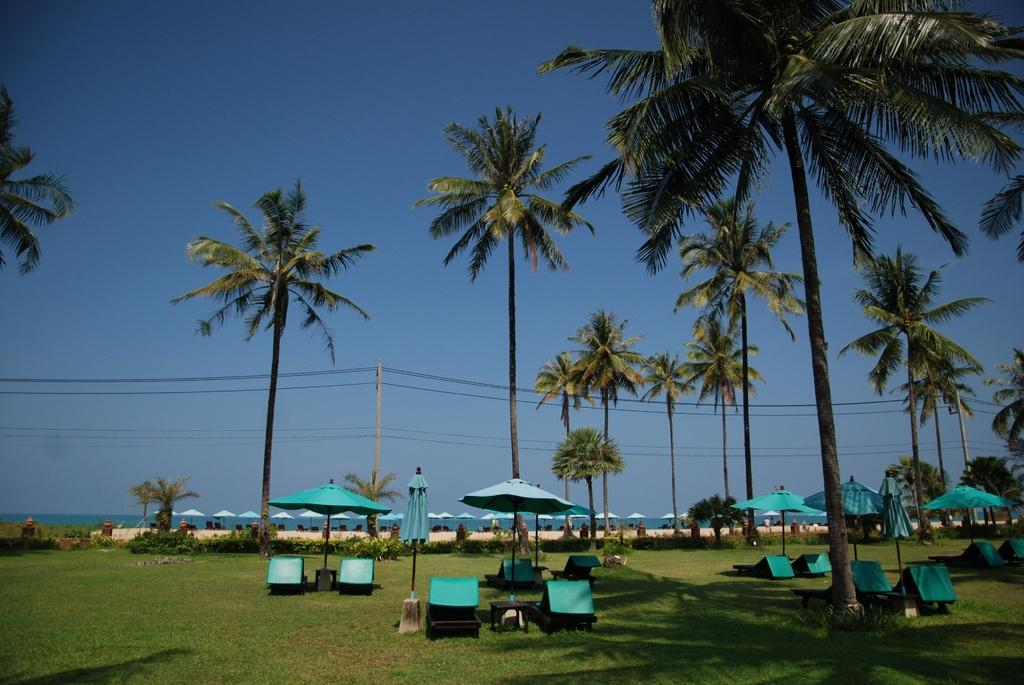What type of outdoor space is depicted in the image? There is a garden in the image. What furniture is present in the garden? The garden contains many chairs. Is there any shade provided in the garden? Yes, there is an umbrella in the garden. What type of vegetation can be seen in the garden? There are tall trees in the garden. What can be seen in the background of the image? There is a beach in the background of the image. What type of jam is being spread on the chairs in the image? There is no jam present in the image; it is a garden with chairs, an umbrella, tall trees, and a beach in the background. 